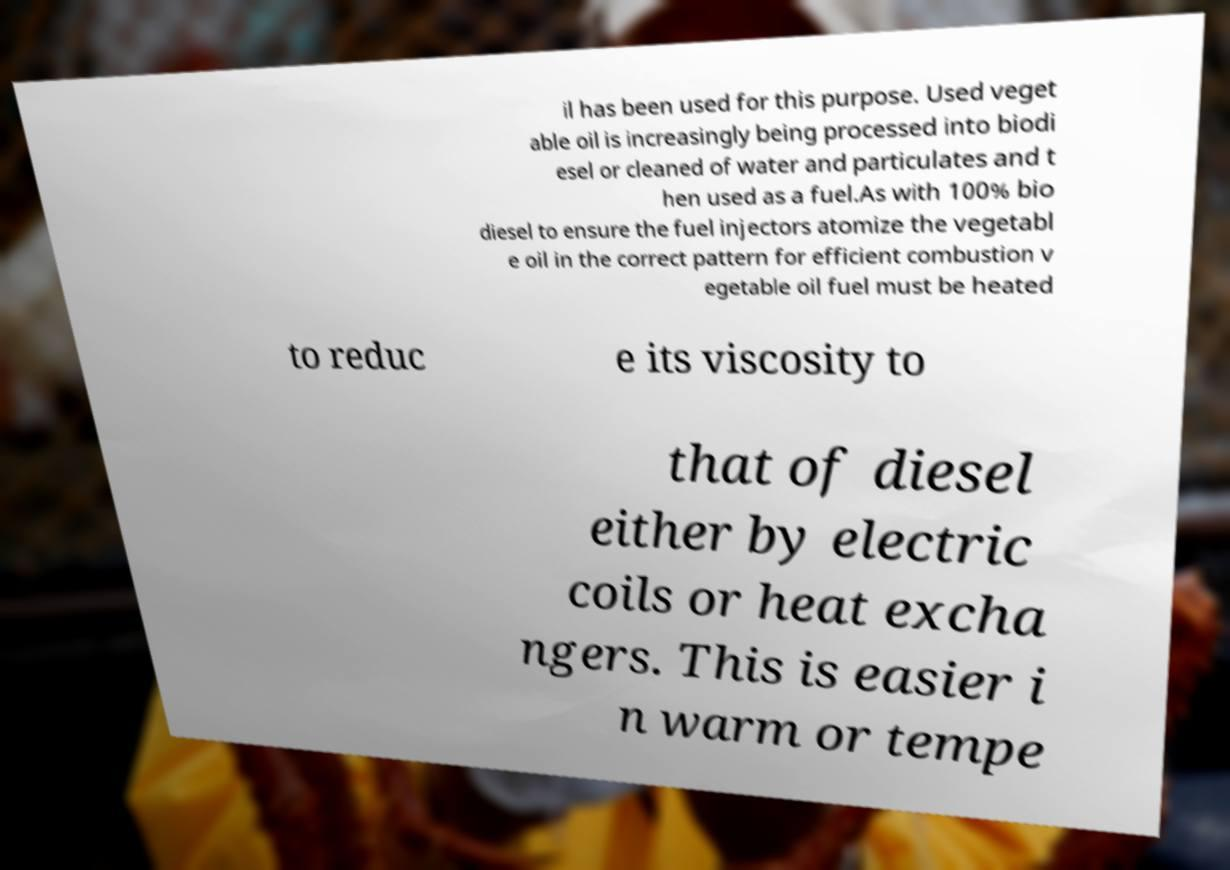Could you extract and type out the text from this image? il has been used for this purpose. Used veget able oil is increasingly being processed into biodi esel or cleaned of water and particulates and t hen used as a fuel.As with 100% bio diesel to ensure the fuel injectors atomize the vegetabl e oil in the correct pattern for efficient combustion v egetable oil fuel must be heated to reduc e its viscosity to that of diesel either by electric coils or heat excha ngers. This is easier i n warm or tempe 